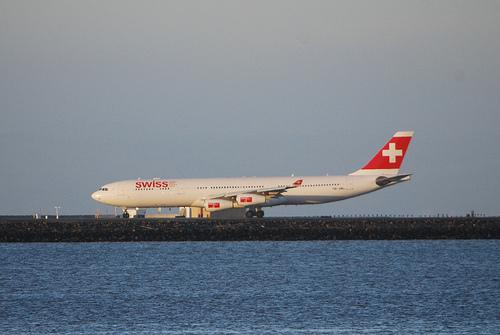Question: where was the photo taken?
Choices:
A. A bike path near water.
B. A road near water.
C. A landing strip near water.
D. A hiking trail near water.
Answer with the letter. Answer: C Question: what is white and red?
Choices:
A. Car.
B. Plane.
C. Boat.
D. Building.
Answer with the letter. Answer: B Question: why does the plane have wings?
Choices:
A. For decoration.
B. To fly.
C. To land.
D. To take off.
Answer with the letter. Answer: B Question: where are windows?
Choices:
A. On the bus.
B. On the taxi.
C. On the plane.
D. On the car.
Answer with the letter. Answer: C 